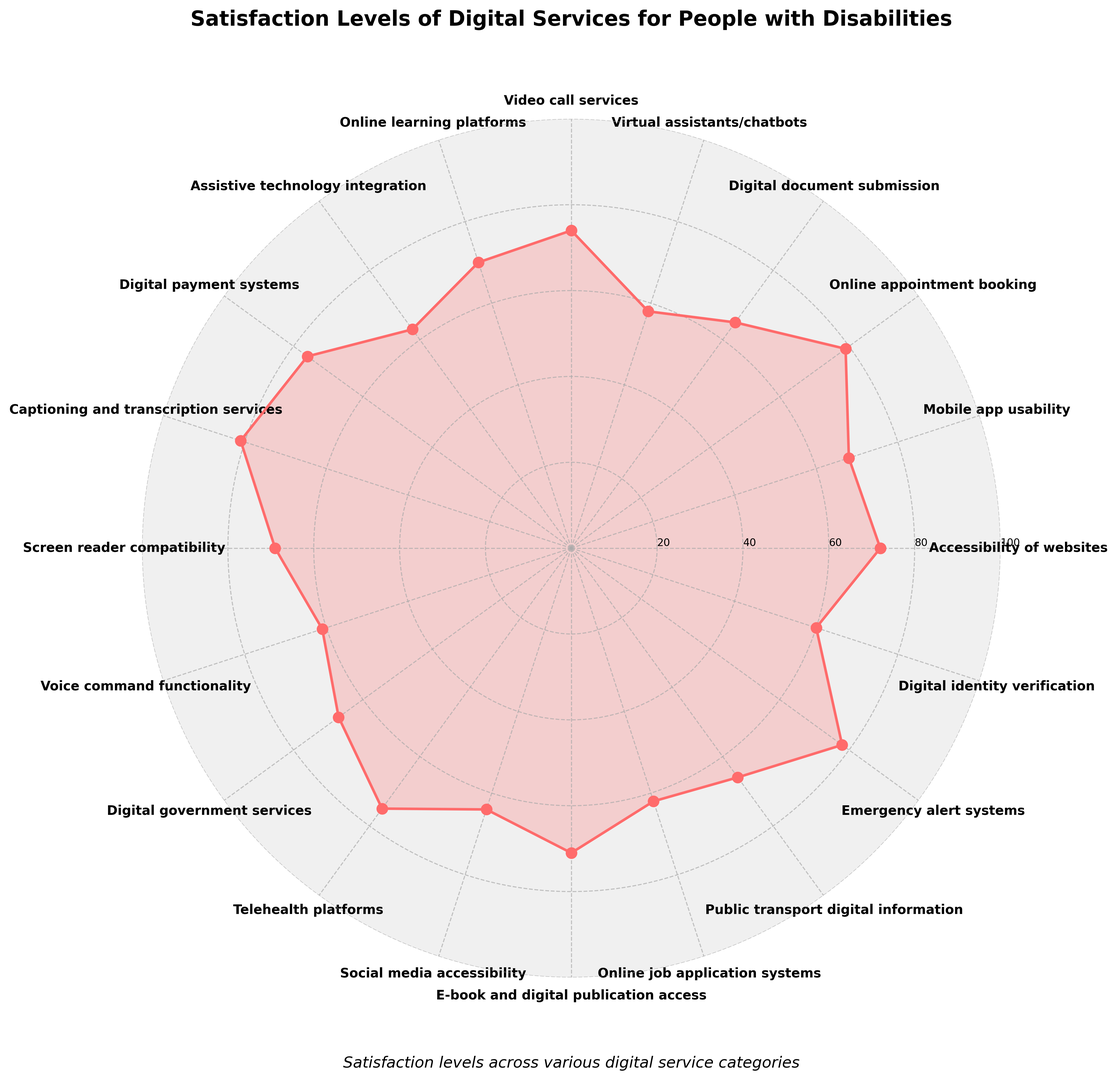Which category has the highest satisfaction level? The category with the highest satisfaction level is identified as the one closest to the outermost edge of the radar chart. In this case, "Captioning and transcription services" has the highest satisfaction level at 81.
Answer: Captioning and transcription services Which category has the lowest satisfaction level? The category with the lowest satisfaction level is identified as the one closest to the center of the radar chart. "Virtual assistants/chatbots" has the lowest satisfaction level at 58.
Answer: Virtual assistants/chatbots What's the average satisfaction level across all categories? Add up all the satisfaction levels and divide by the number of categories: (72 + 68 + 79 + 65 + 58 + 74 + 70 + 63 + 76 + 81 + 69 + 61 + 67 + 75 + 64 + 71 + 62 + 66 + 78 + 60) / 20 = 69.3.
Answer: 69.3 Which two categories have the closest satisfaction levels? Identify the two categories whose satisfaction values are closest by comparing the differences. "Accessibility of websites" (72) and "Screen reader compatibility" (69) have a difference of 3, which is the smallest among all pairs.
Answer: Accessibility of websites and Screen reader compatibility Are there more categories with satisfaction levels above 70 or below 70? Count the categories with satisfaction levels above and below 70. There are 10 categories above 70 and 10 categories below 70.
Answer: They are equal How many categories have satisfaction levels between 60 and 70 inclusive? Count the categories where satisfaction levels fall between 60 and 70 inclusive. The categories are: Mobile app usability (68), Digital document submission (65), Screen reader compatibility (69), Voice command functionality (61), Digital government services (67), Social media accessibility (64), E-book and digital publication access (71, not within range), Online job application systems (62), Public transport digital information (66), Digital identity verification (60).
Answer: 8 Which categories have satisfaction levels greater than or equal to 75? Identify and list the categories with satisfaction levels 75 or higher: Online appointment booking (79), Video call services (74, not above 75), Digital payment systems (76), Captioning and transcription services (81), Telehealth platforms (75), Emergency alert systems (78).
Answer: Online appointment booking, Digital payment systems, Captioning and transcription services, Telehealth platforms, Emergency alert systems What is the satisfaction range of digital services for people with disabilities? Subtract the lowest satisfaction level from the highest satisfaction level: 81 (Captioning and transcription services) - 58 (Virtual assistants/chatbots) = 23.
Answer: 23 Which service categories are below the median satisfaction level? Calculate the median satisfaction level: sort the satisfaction levels and find the middle value(s). The sorted satisfaction levels are 58, 60, 61, 62, 63, 64, 65, 66, 67, 68, 69, 70, 71, 72, 74, 75, 76, 78, 79, 81. The median lies between the 10th and 11th values, which are both 70. So categories below 70 are: Virtual assistants/chatbots (58), Digital identity verification (60), Voice command functionality (61), Online job application systems (62), Assistive technology integration (63), Social media accessibility (64), Digital document submission (65), Public transport digital information (66), Digital government services (67), Mobile app usability (68), Screen reader compatibility (69, equal to median).
Answer: Virtual assistants/chatbots, Digital identity verification, Voice command functionality, Online job application systems, Assistive technology integration, Social media accessibility, Digital document submission, Public transport digital information, Digital government services, Mobile app usability 